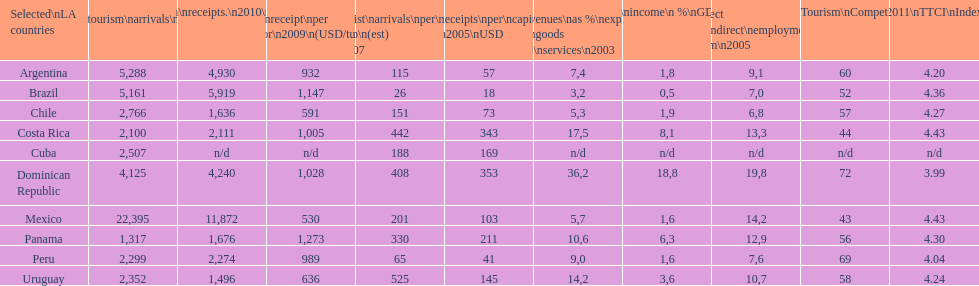What is the last country listed on this chart? Uruguay. 